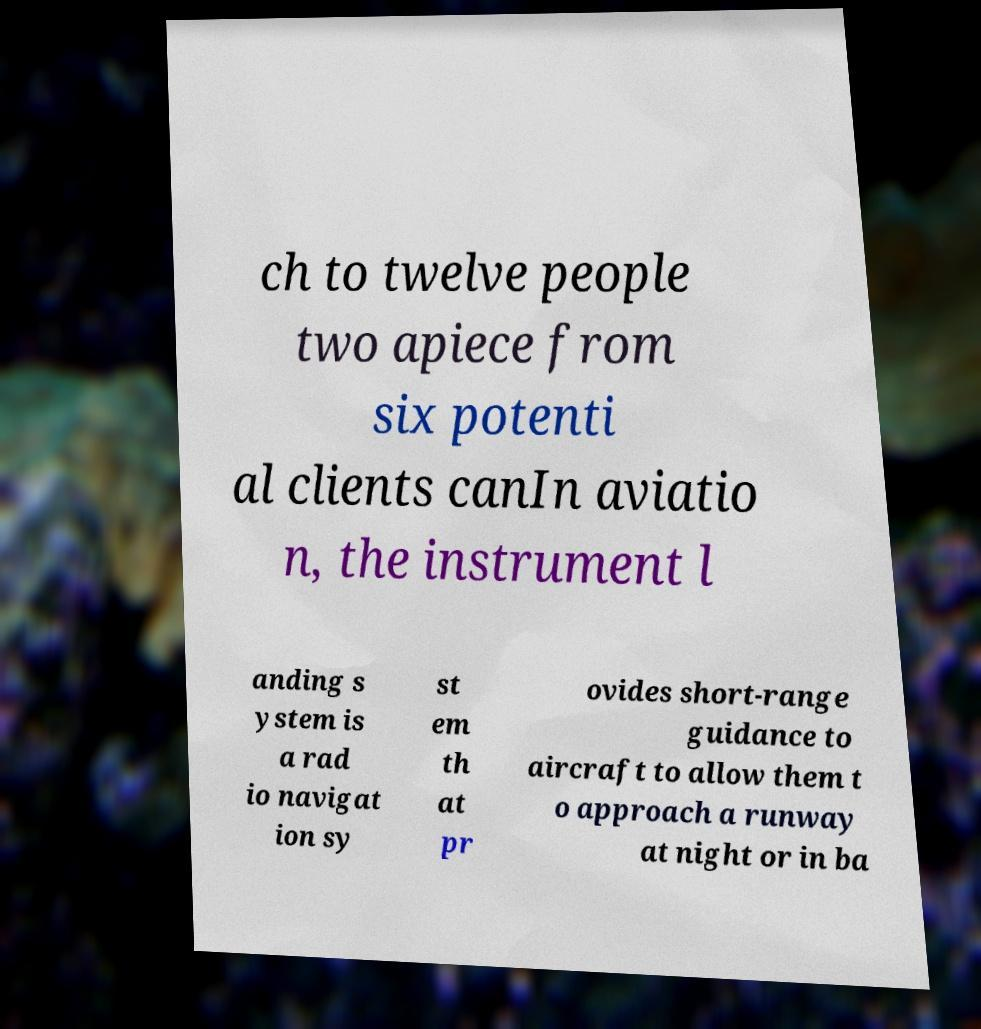I need the written content from this picture converted into text. Can you do that? ch to twelve people two apiece from six potenti al clients canIn aviatio n, the instrument l anding s ystem is a rad io navigat ion sy st em th at pr ovides short-range guidance to aircraft to allow them t o approach a runway at night or in ba 